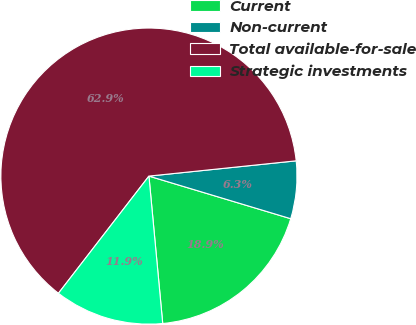Convert chart. <chart><loc_0><loc_0><loc_500><loc_500><pie_chart><fcel>Current<fcel>Non-current<fcel>Total available-for-sale<fcel>Strategic investments<nl><fcel>18.87%<fcel>6.29%<fcel>62.89%<fcel>11.95%<nl></chart> 